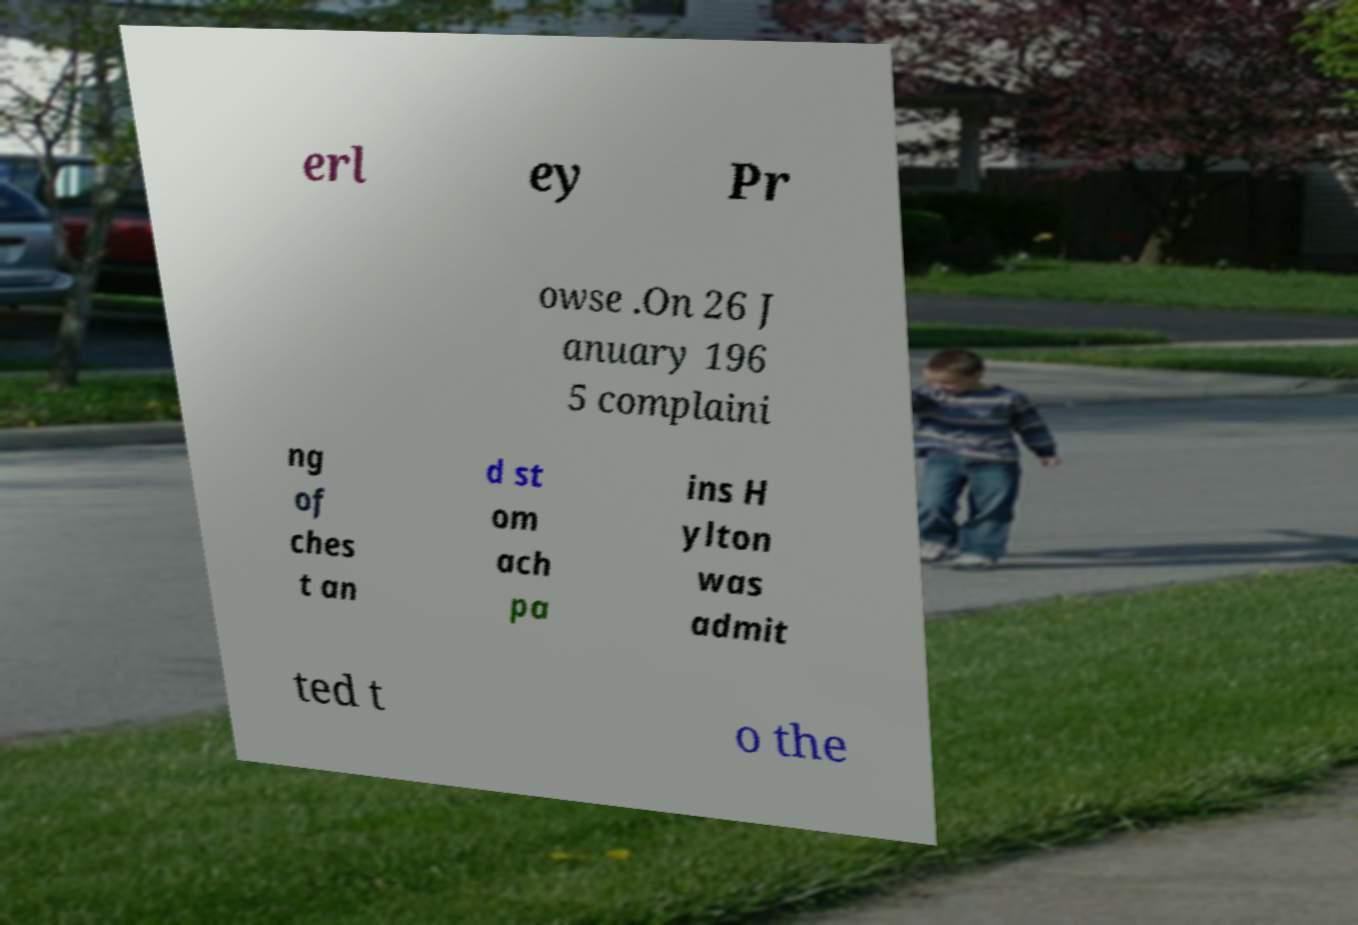Can you accurately transcribe the text from the provided image for me? erl ey Pr owse .On 26 J anuary 196 5 complaini ng of ches t an d st om ach pa ins H ylton was admit ted t o the 